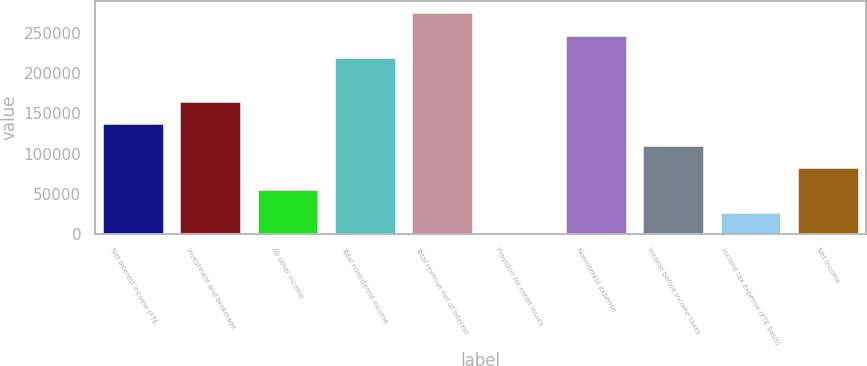Convert chart. <chart><loc_0><loc_0><loc_500><loc_500><bar_chart><fcel>Net interest income (FTE<fcel>Investment and brokerage<fcel>All other income<fcel>Total noninterest income<fcel>Total revenue net of interest<fcel>Provision for credit losses<fcel>Noninterest expense<fcel>Income before income taxes<fcel>Income tax expense (FTE basis)<fcel>Net income<nl><fcel>138000<fcel>165590<fcel>55230.8<fcel>220770<fcel>275950<fcel>51<fcel>248360<fcel>110411<fcel>27640.9<fcel>82820.7<nl></chart> 